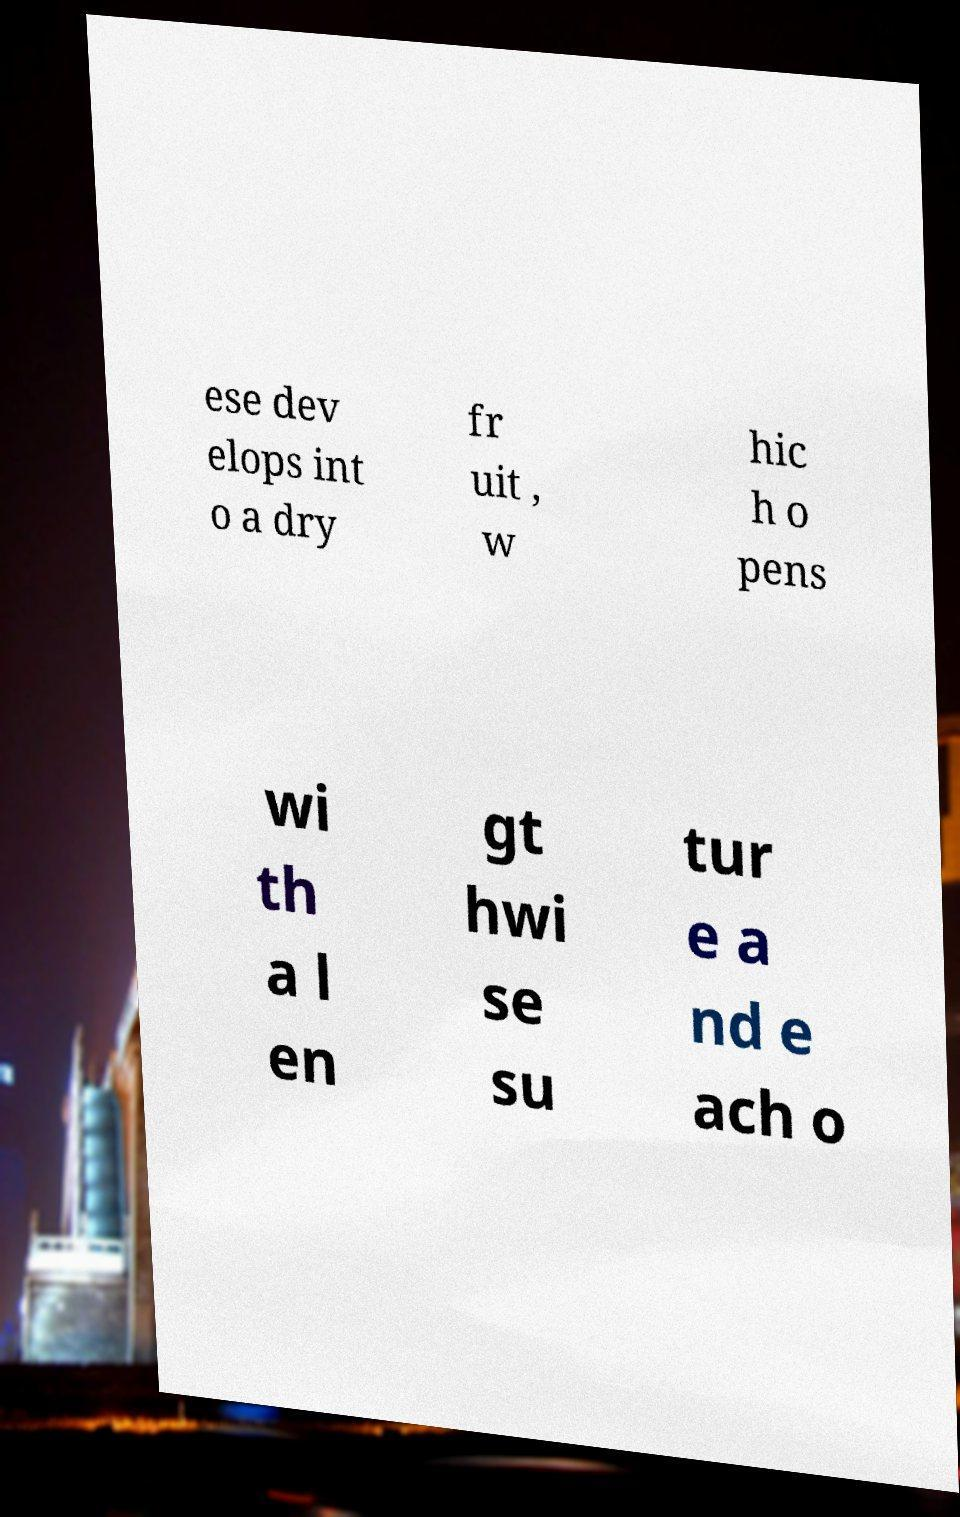Please identify and transcribe the text found in this image. ese dev elops int o a dry fr uit , w hic h o pens wi th a l en gt hwi se su tur e a nd e ach o 